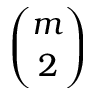Convert formula to latex. <formula><loc_0><loc_0><loc_500><loc_500>\binom { m } { 2 }</formula> 